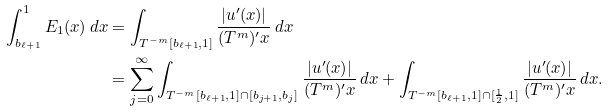<formula> <loc_0><loc_0><loc_500><loc_500>\int _ { b _ { \ell + 1 } } ^ { 1 } E _ { 1 } ( x ) \, d x & = \int _ { T ^ { - m } [ b _ { \ell + 1 } , 1 ] } \frac { | u ^ { \prime } ( x ) | } { ( T ^ { m } ) ^ { \prime } x } \, d x \\ & = \sum _ { j = 0 } ^ { \infty } \int _ { T ^ { - m } [ b _ { \ell + 1 } , 1 ] \cap [ b _ { j + 1 } , b _ { j } ] } \frac { | u ^ { \prime } ( x ) | } { ( T ^ { m } ) ^ { \prime } x } \, d x + \int _ { T ^ { - m } [ b _ { \ell + 1 } , 1 ] \cap [ \frac { 1 } { 2 } , 1 ] } \frac { | u ^ { \prime } ( x ) | } { ( T ^ { m } ) ^ { \prime } x } \, d x .</formula> 